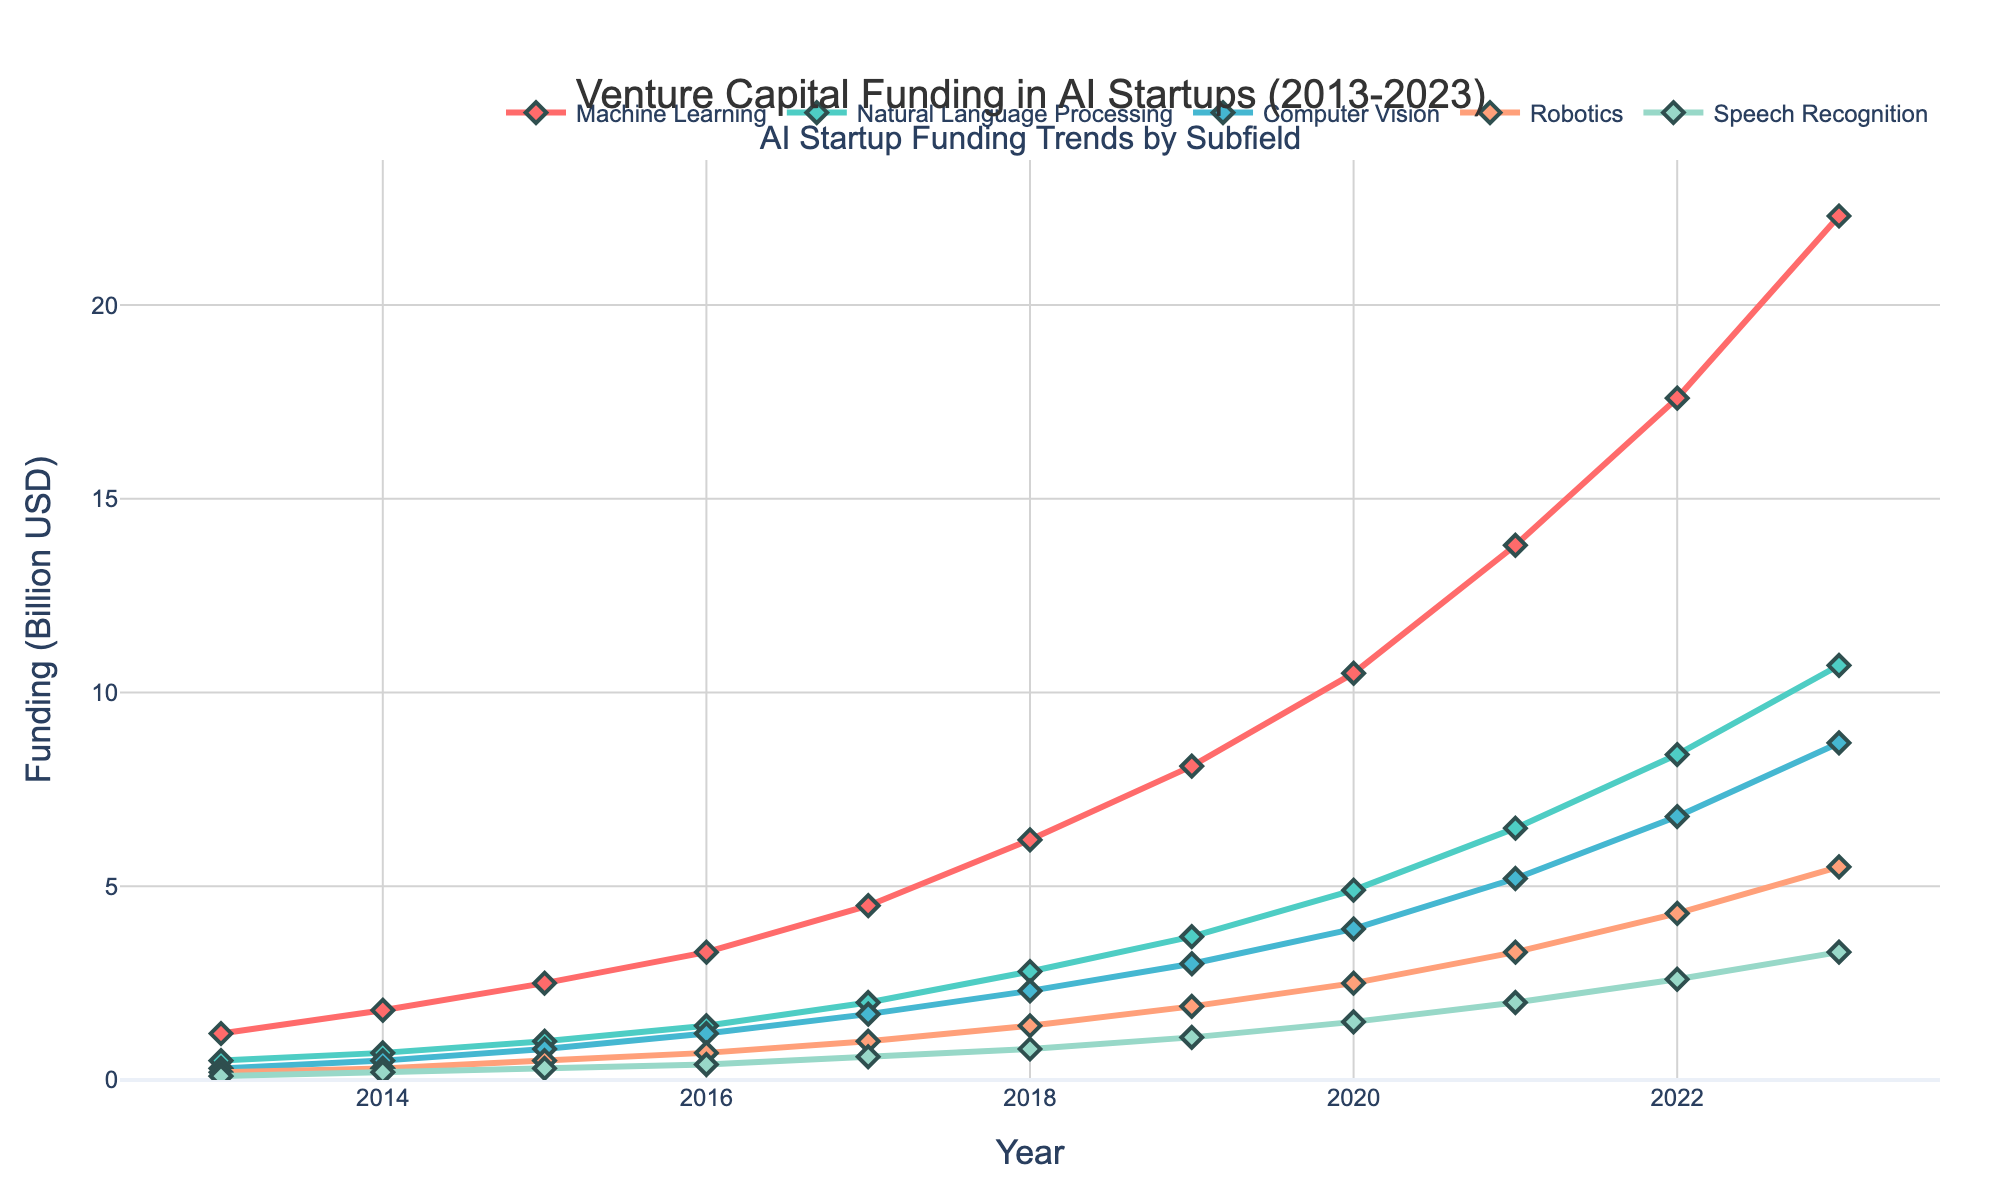What was the funding amount for Machine Learning in 2016? Locate the year 2016 on the x-axis and the corresponding point for Machine Learning on the y-axis, which reads 3.3 billion USD.
Answer: 3.3 billion USD Which AI subfield had the highest funding in 2023? Observe the lines at the rightmost data point (2023) and identify that Machine Learning has the highest position among them, indicating the highest funding.
Answer: Machine Learning Between which two years did Natural Language Processing funding see the greatest increase? Track the Natural Language Processing line and observe the steepest ascent. The steepest increase can be seen between 2022 and 2023, going from 8.4 to 10.7 billion USD.
Answer: 2022 to 2023 How does the funding for Computer Vision in 2019 compare to that in 2023? Locate the points for Computer Vision in 2019 and 2023 on the chart. In 2019, it was 3.0 billion USD and in 2023, it was 8.7 billion USD.
Answer: 2019 was less than 2023 What is the average funding for Robotics over the whole decade? Calculate the average by summing the yearly funding amounts for Robotics and then dividing by the number of years. (0.2+0.3+0.5+0.7+1.0+1.4+1.9+2.5+3.3+4.3+5.5)/11 = 1.96 billion USD.
Answer: 1.96 billion USD By how much did the funding for Speech Recognition increase from 2015 to 2020? Find the funding values for 2015 and 2020, which are 0.3 and 1.5 billion USD respectively. Then subtract the 2015 value from the 2020 value: 1.5 - 0.3 = 1.2 billion USD.
Answer: 1.2 billion USD What is the trend of Machine Learning funding over the decade? Following the Machine Learning line from 2013 to 2023, the trend is consistently upward, indicating a steady increase in funding each year.
Answer: Increasing Which subfield had the least funding in 2013, and what was the value? At the leftmost data point (2013), compare the heights of the lines. Speech Recognition had the lowest funding at 0.1 billion USD.
Answer: Speech Recognition, 0.1 billion USD If we sum the funding amounts for Computer Vision and Robotics for 2021, what is the total? Add the funding values for both subfields in 2021: 5.2 billion USD (Computer Vision) + 3.3 billion USD (Robotics) = 8.5 billion USD.
Answer: 8.5 billion USD What color line represents funding trends in Natural Language Processing? Observe the color corresponding to the Natural Language Processing label in the legend, which is green.
Answer: Green 